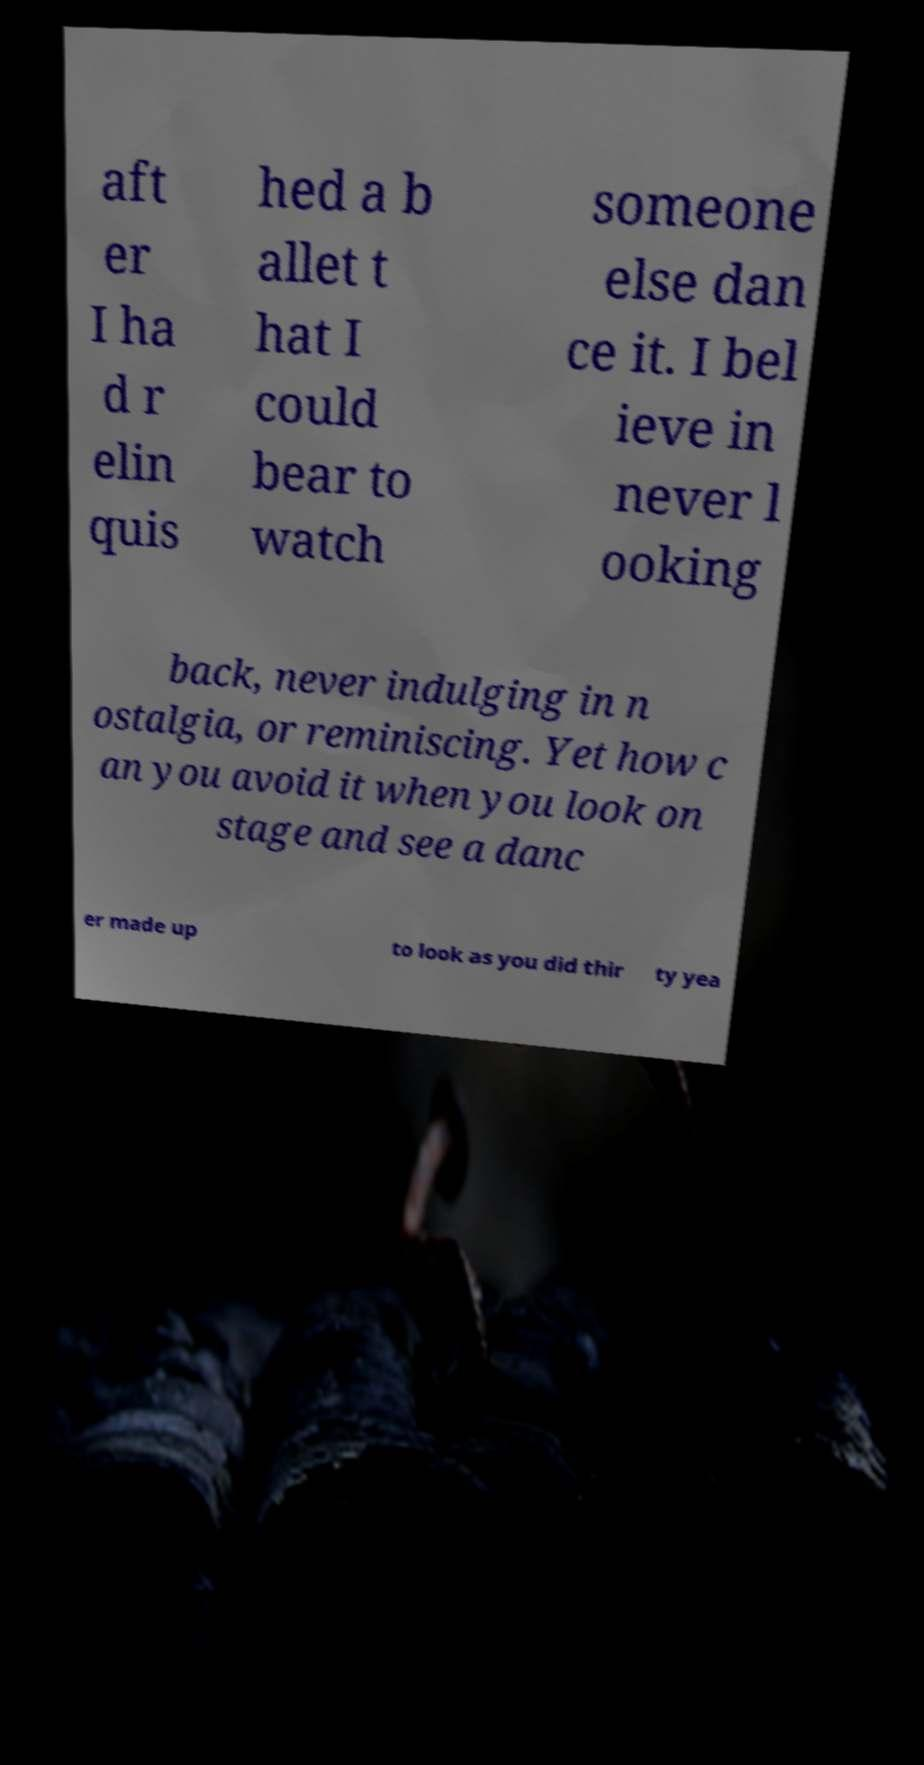For documentation purposes, I need the text within this image transcribed. Could you provide that? aft er I ha d r elin quis hed a b allet t hat I could bear to watch someone else dan ce it. I bel ieve in never l ooking back, never indulging in n ostalgia, or reminiscing. Yet how c an you avoid it when you look on stage and see a danc er made up to look as you did thir ty yea 